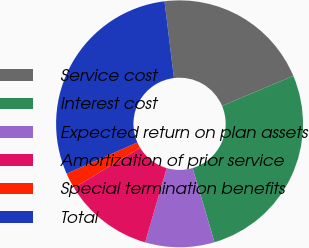Convert chart to OTSL. <chart><loc_0><loc_0><loc_500><loc_500><pie_chart><fcel>Service cost<fcel>Interest cost<fcel>Expected return on plan assets<fcel>Amortization of prior service<fcel>Special termination benefits<fcel>Total<nl><fcel>20.6%<fcel>26.78%<fcel>9.06%<fcel>11.83%<fcel>2.06%<fcel>29.67%<nl></chart> 